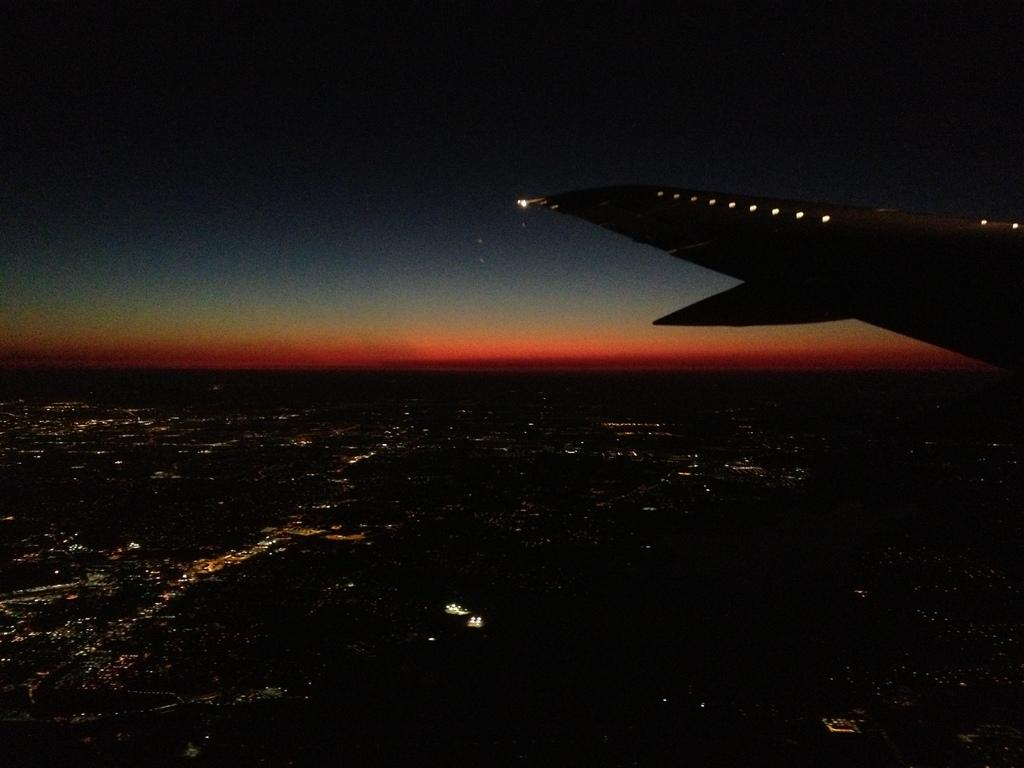What is the perspective of the image? The image is taken from a flight. What can be observed about the background of the image? The background of the image is dark. What type of lead is being used to secure the boot in the image? There is no lead or boot present in the image; it is taken from a flight with a dark background. 